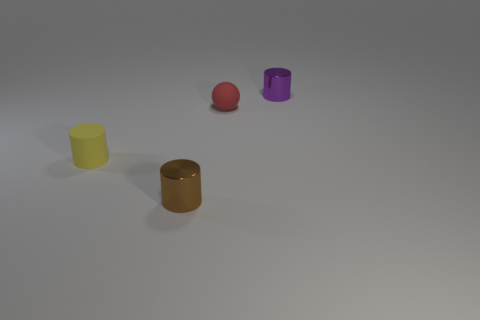What is the color of the small metallic cylinder behind the tiny yellow rubber cylinder?
Offer a terse response. Purple. There is a shiny object behind the brown cylinder; is it the same shape as the small yellow matte thing?
Offer a very short reply. Yes. There is a purple object that is the same shape as the brown metallic thing; what is its material?
Ensure brevity in your answer.  Metal. What number of things are rubber objects that are on the right side of the tiny brown thing or metal things in front of the tiny yellow object?
Your answer should be compact. 2. The other object that is the same material as the purple thing is what shape?
Keep it short and to the point. Cylinder. How many purple metallic objects are there?
Keep it short and to the point. 1. What number of objects are either small matte objects that are to the right of the brown metallic thing or tiny gray matte cylinders?
Your answer should be very brief. 1. How many other things are there of the same color as the small rubber ball?
Offer a terse response. 0. How many tiny things are either gray blocks or brown metallic objects?
Offer a terse response. 1. Are there more small rubber balls than green blocks?
Your response must be concise. Yes. 